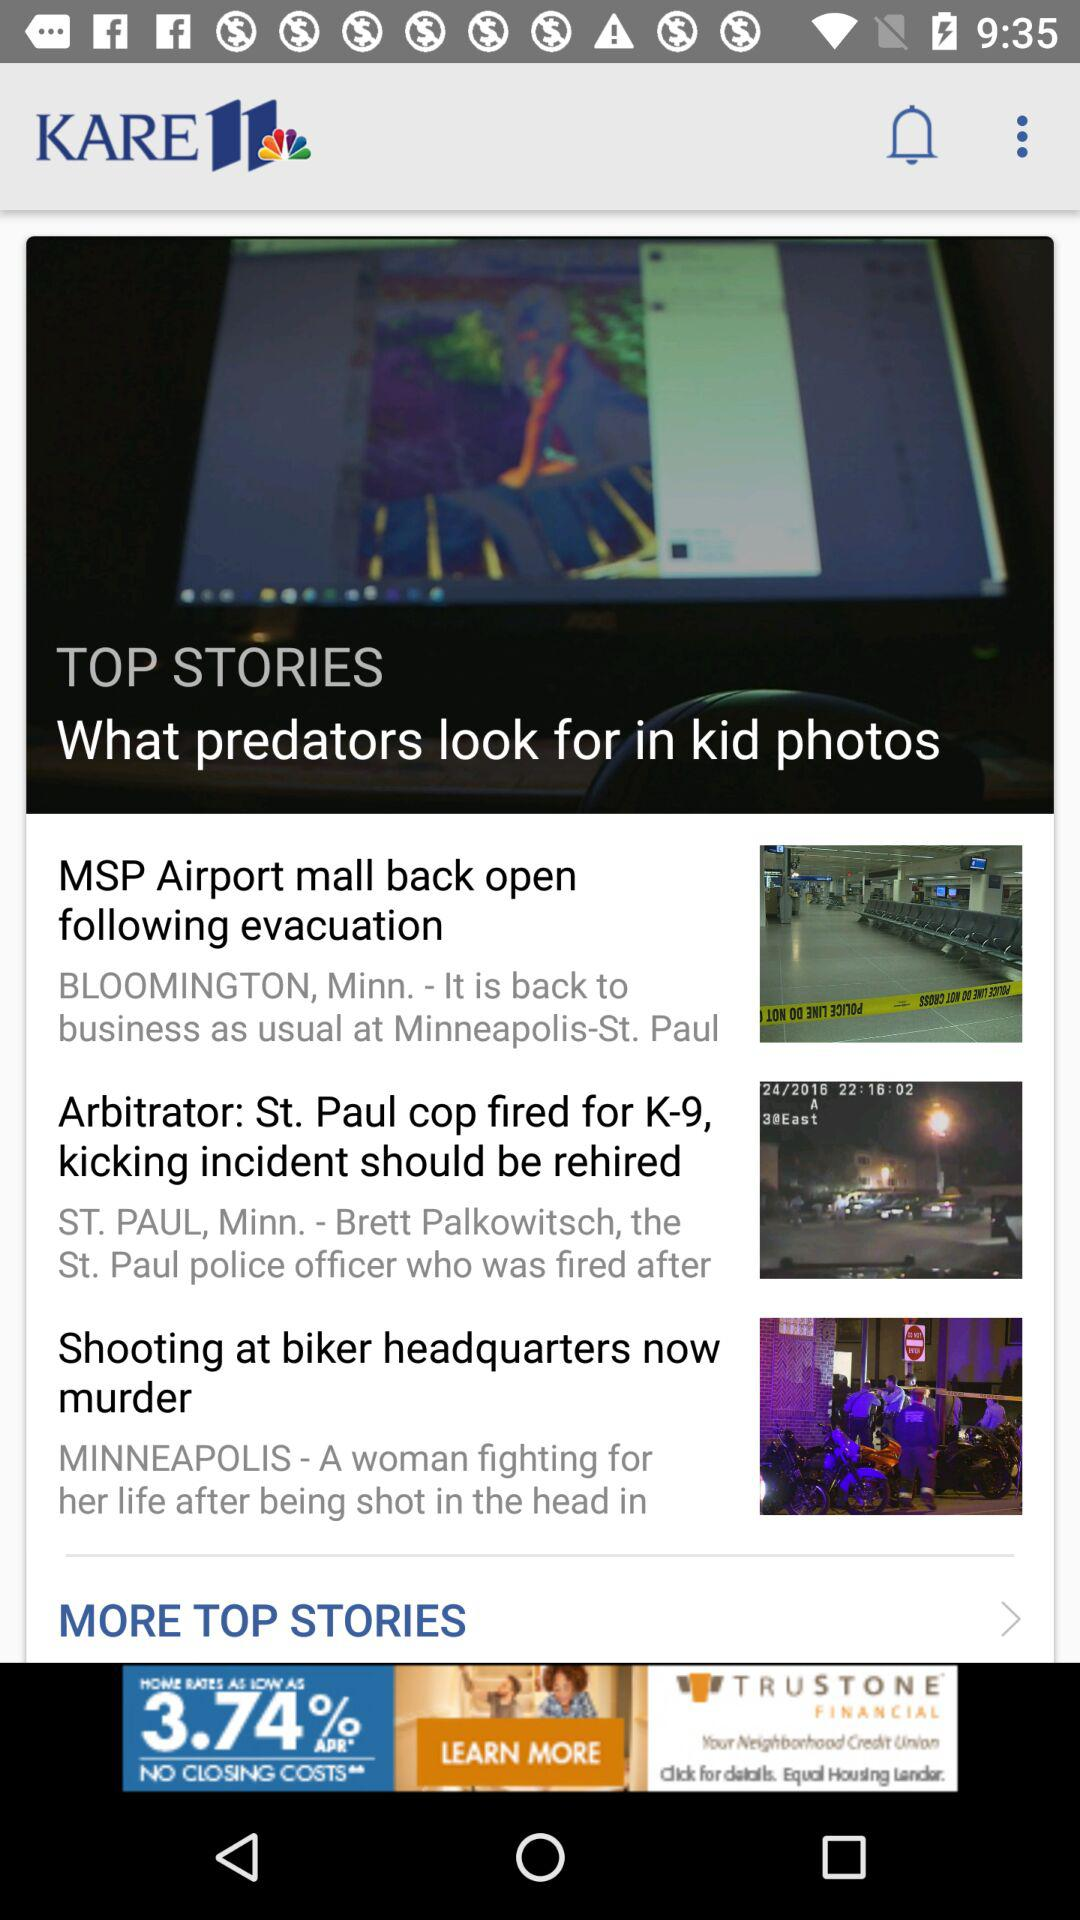What is the name of the application? The name of the application is "KARE 11". 